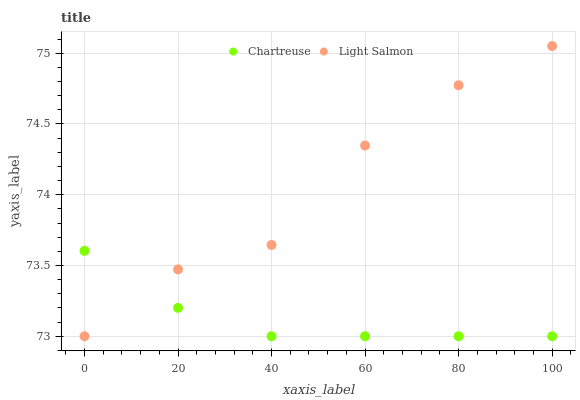Does Chartreuse have the minimum area under the curve?
Answer yes or no. Yes. Does Light Salmon have the maximum area under the curve?
Answer yes or no. Yes. Does Light Salmon have the minimum area under the curve?
Answer yes or no. No. Is Chartreuse the smoothest?
Answer yes or no. Yes. Is Light Salmon the roughest?
Answer yes or no. Yes. Is Light Salmon the smoothest?
Answer yes or no. No. Does Chartreuse have the lowest value?
Answer yes or no. Yes. Does Light Salmon have the highest value?
Answer yes or no. Yes. Does Light Salmon intersect Chartreuse?
Answer yes or no. Yes. Is Light Salmon less than Chartreuse?
Answer yes or no. No. Is Light Salmon greater than Chartreuse?
Answer yes or no. No. 